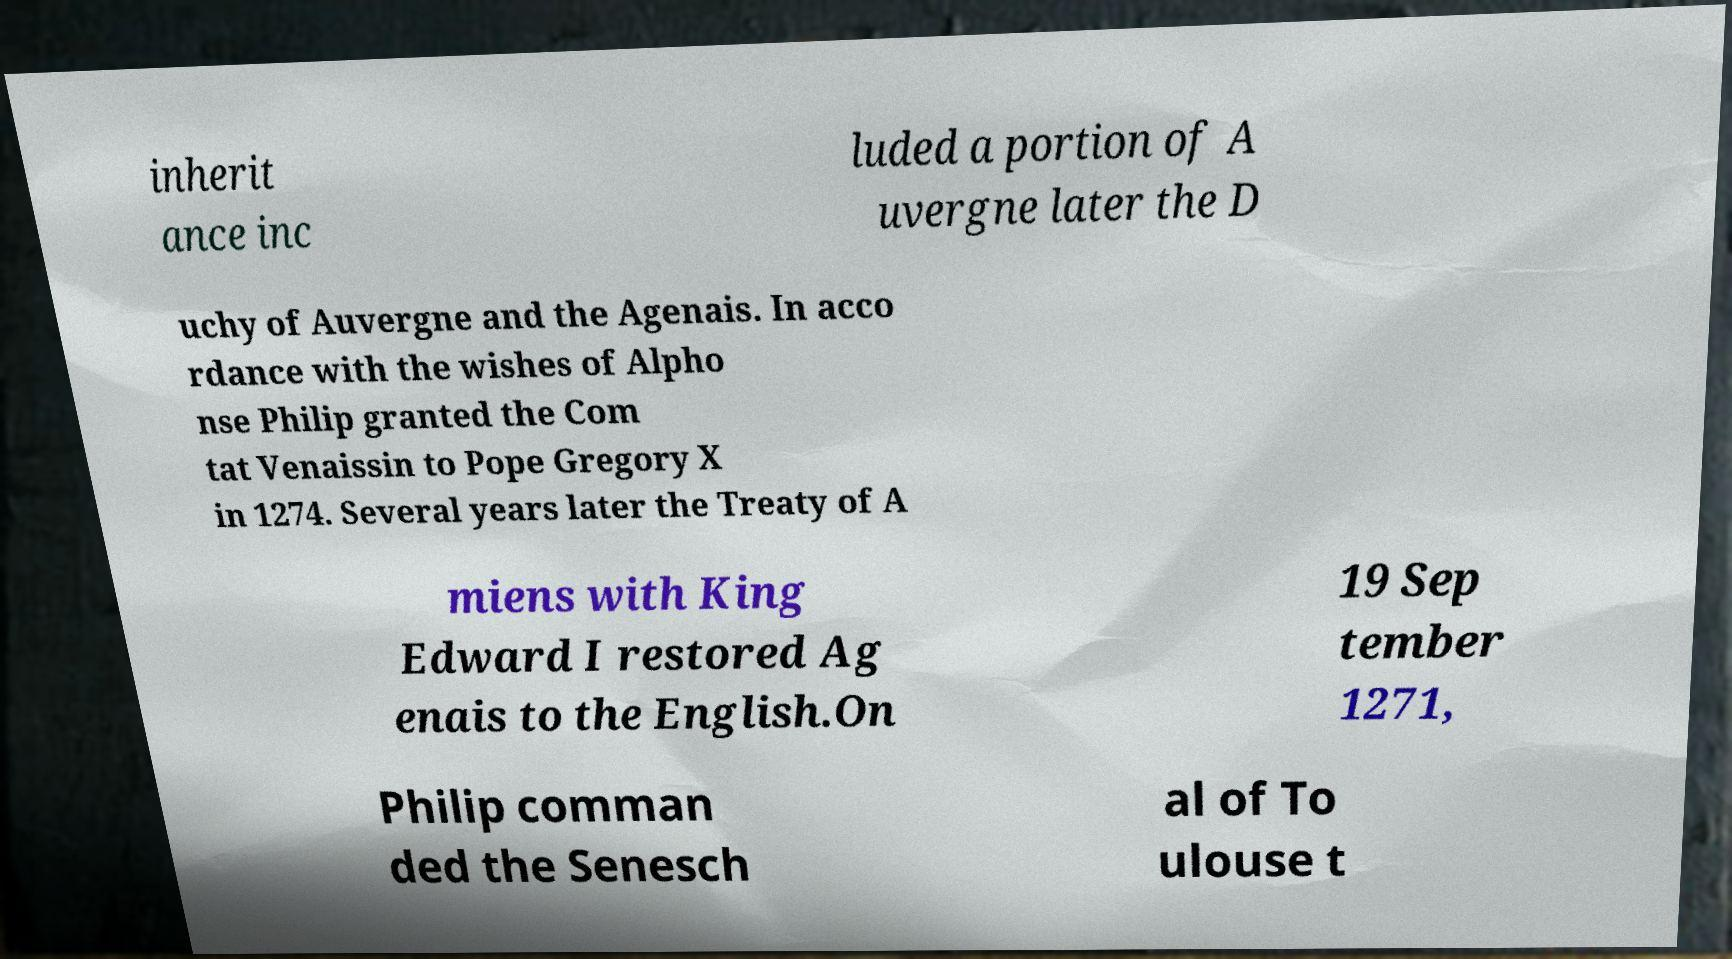There's text embedded in this image that I need extracted. Can you transcribe it verbatim? inherit ance inc luded a portion of A uvergne later the D uchy of Auvergne and the Agenais. In acco rdance with the wishes of Alpho nse Philip granted the Com tat Venaissin to Pope Gregory X in 1274. Several years later the Treaty of A miens with King Edward I restored Ag enais to the English.On 19 Sep tember 1271, Philip comman ded the Senesch al of To ulouse t 